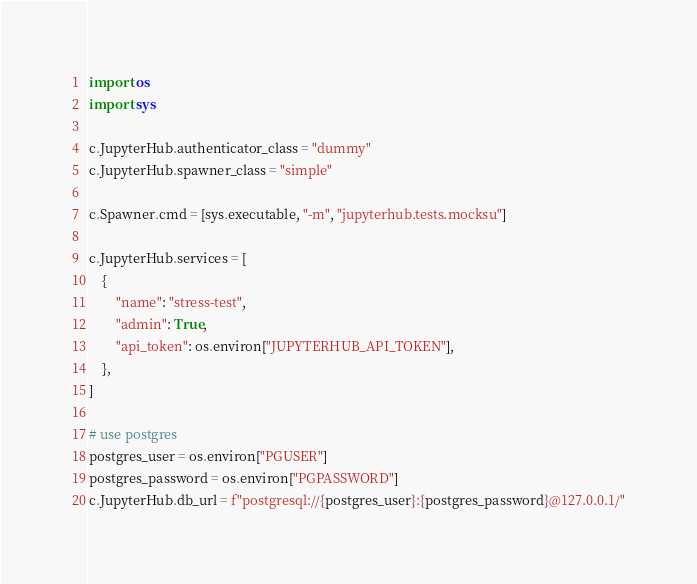<code> <loc_0><loc_0><loc_500><loc_500><_Python_>import os
import sys

c.JupyterHub.authenticator_class = "dummy"
c.JupyterHub.spawner_class = "simple"

c.Spawner.cmd = [sys.executable, "-m", "jupyterhub.tests.mocksu"]

c.JupyterHub.services = [
	{
		"name": "stress-test",
		"admin": True,
		"api_token": os.environ["JUPYTERHUB_API_TOKEN"],
	},
]

# use postgres
postgres_user = os.environ["PGUSER"]
postgres_password = os.environ["PGPASSWORD"]
c.JupyterHub.db_url = f"postgresql://{postgres_user}:{postgres_password}@127.0.0.1/"
</code> 